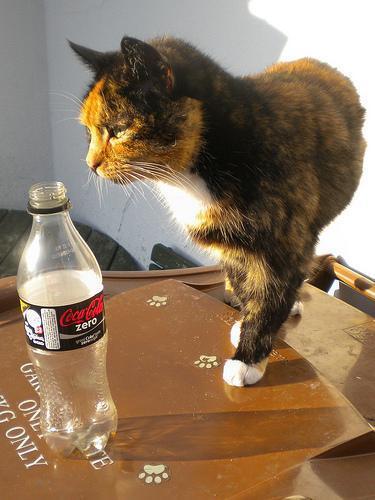How many animals in the picture?
Give a very brief answer. 1. 